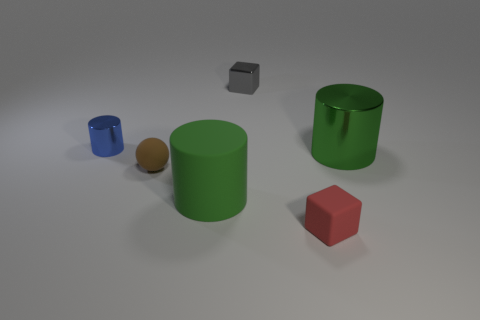Add 2 tiny blocks. How many objects exist? 8 Subtract all balls. How many objects are left? 5 Subtract 0 purple blocks. How many objects are left? 6 Subtract all tiny rubber things. Subtract all red matte blocks. How many objects are left? 3 Add 6 matte things. How many matte things are left? 9 Add 5 tiny brown shiny cylinders. How many tiny brown shiny cylinders exist? 5 